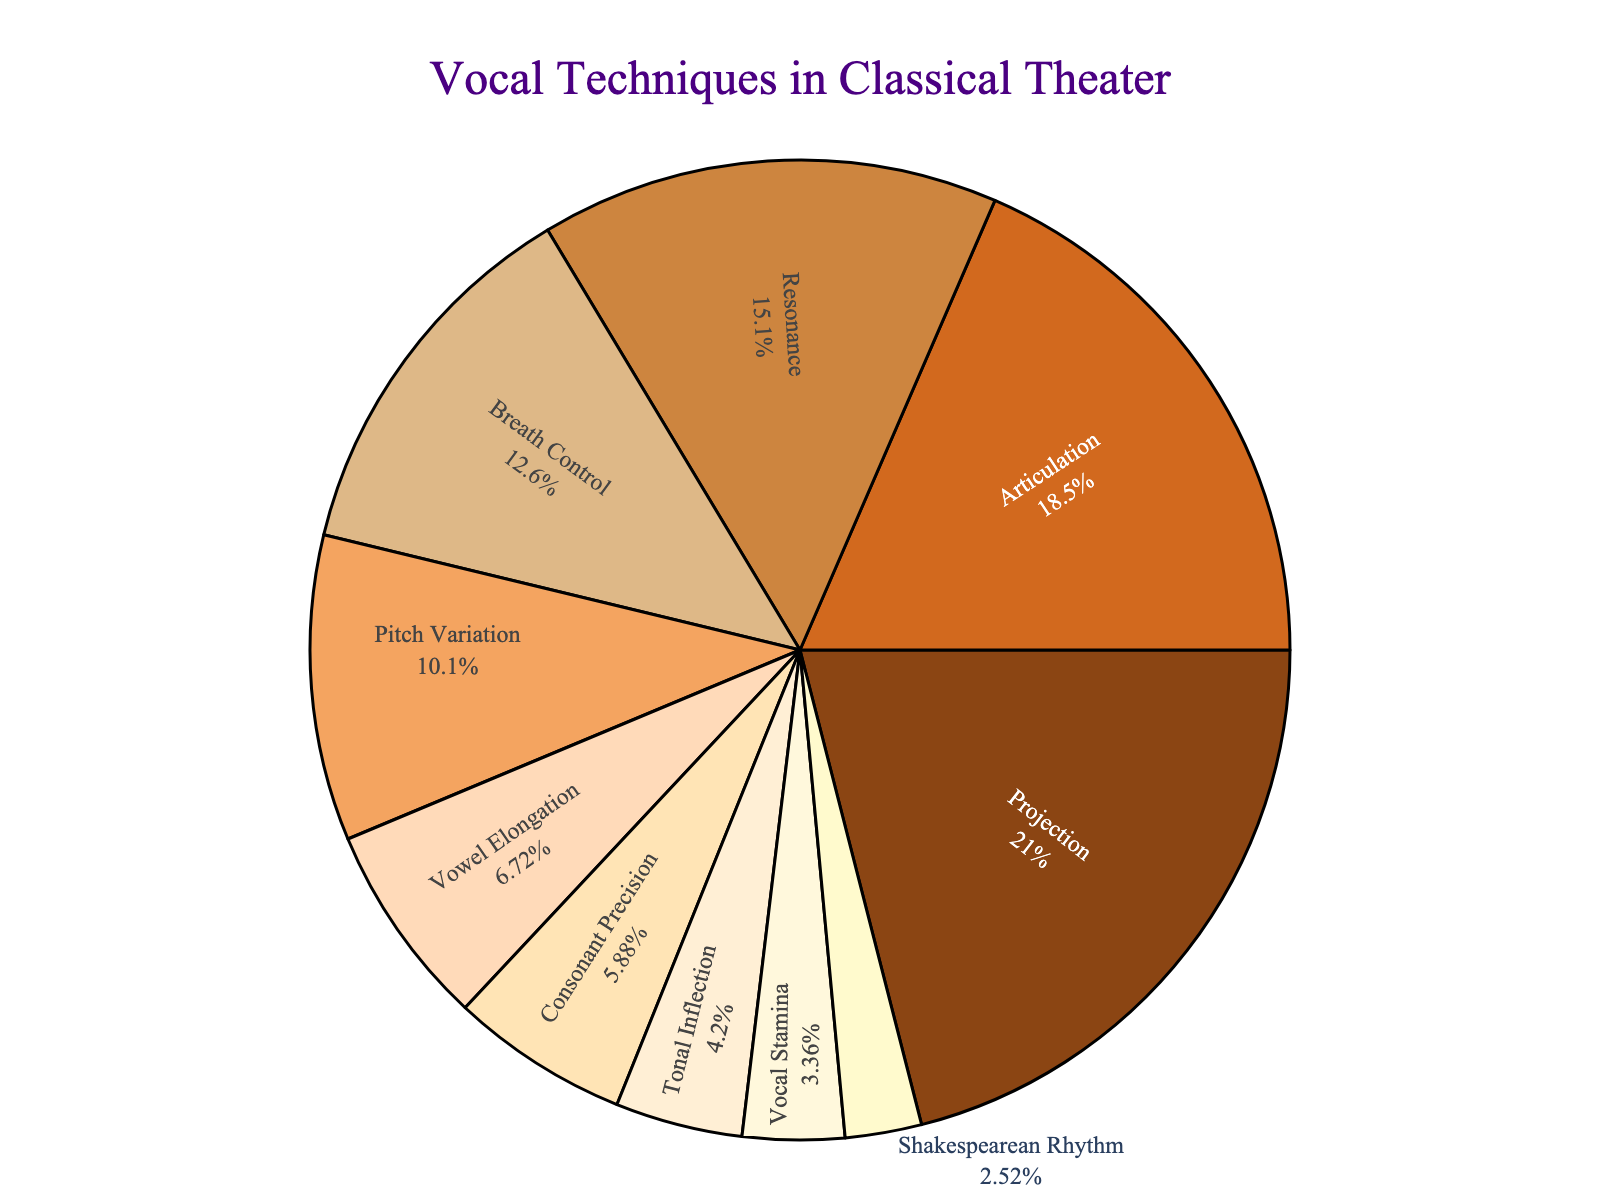Which technique has the highest percentage of usage in classical theater? The technique with the highest percentage can be identified by referring to the segment with the largest portion of the pie chart.
Answer: Projection What is the combined percentage of Projection and Articulation techniques? To find the combined percentage, sum the individual percentages: Projection (25%) and Articulation (22%).
Answer: 47% Which technique is used less frequently, Pitch Variation or Breath Control? Compare the percentages of Pitch Variation and Breath Control; Pitch Variation has 12%, while Breath Control has 15%, making Pitch Variation less frequent.
Answer: Pitch Variation How much more is the percentage of Resonance compared to Shakespearean Rhythm? Subtract the percentage of Shakespearean Rhythm (3%) from that of Resonance (18%).
Answer: 15% What is the percentage difference between Consonant Precision and Vocal Stamina? Subtract the percentage of Vocal Stamina (4%) from that of Consonant Precision (7%).
Answer: 3% What are the techniques that have a percentage below 10%? Identify the techniques from the pie chart with a percentage less than 10%. These are Vowel Elongation (8%), Consonant Precision (7%), Tonal Inflection (5%), Vocal Stamina (4%), and Shakespearean Rhythm (3%).
Answer: Vowel Elongation, Consonant Precision, Tonal Inflection, Vocal Stamina, Shakespearean Rhythm What is the average percentage of the techniques listed in the pie chart? To find the average, sum all the techniques' percentages (100%) and divide by the number of techniques (10). 100 / 10 = 10.
Answer: 10% Is the percentage usage of Breath Control greater than the combined percentage of Tonal Inflection and Vocal Stamina? Compare Breath Control's percentage (15%) with the sum of Tonal Inflection (5%) and Vocal Stamina (4%), which is 9%. 15% is greater than 9%.
Answer: Yes What is the total percentage of all techniques used in classical theater? Sum the percentages of all listed techniques, which should be a full circle in a pie chart.
Answer: 100% Which techniques are represented by the two smallest slices in the pie chart? The smallest percentages are represented by Vocal Stamina (4%) and Shakespearean Rhythm (3%), which will be the smallest slices.
Answer: Vocal Stamina, Shakespearean Rhythm 